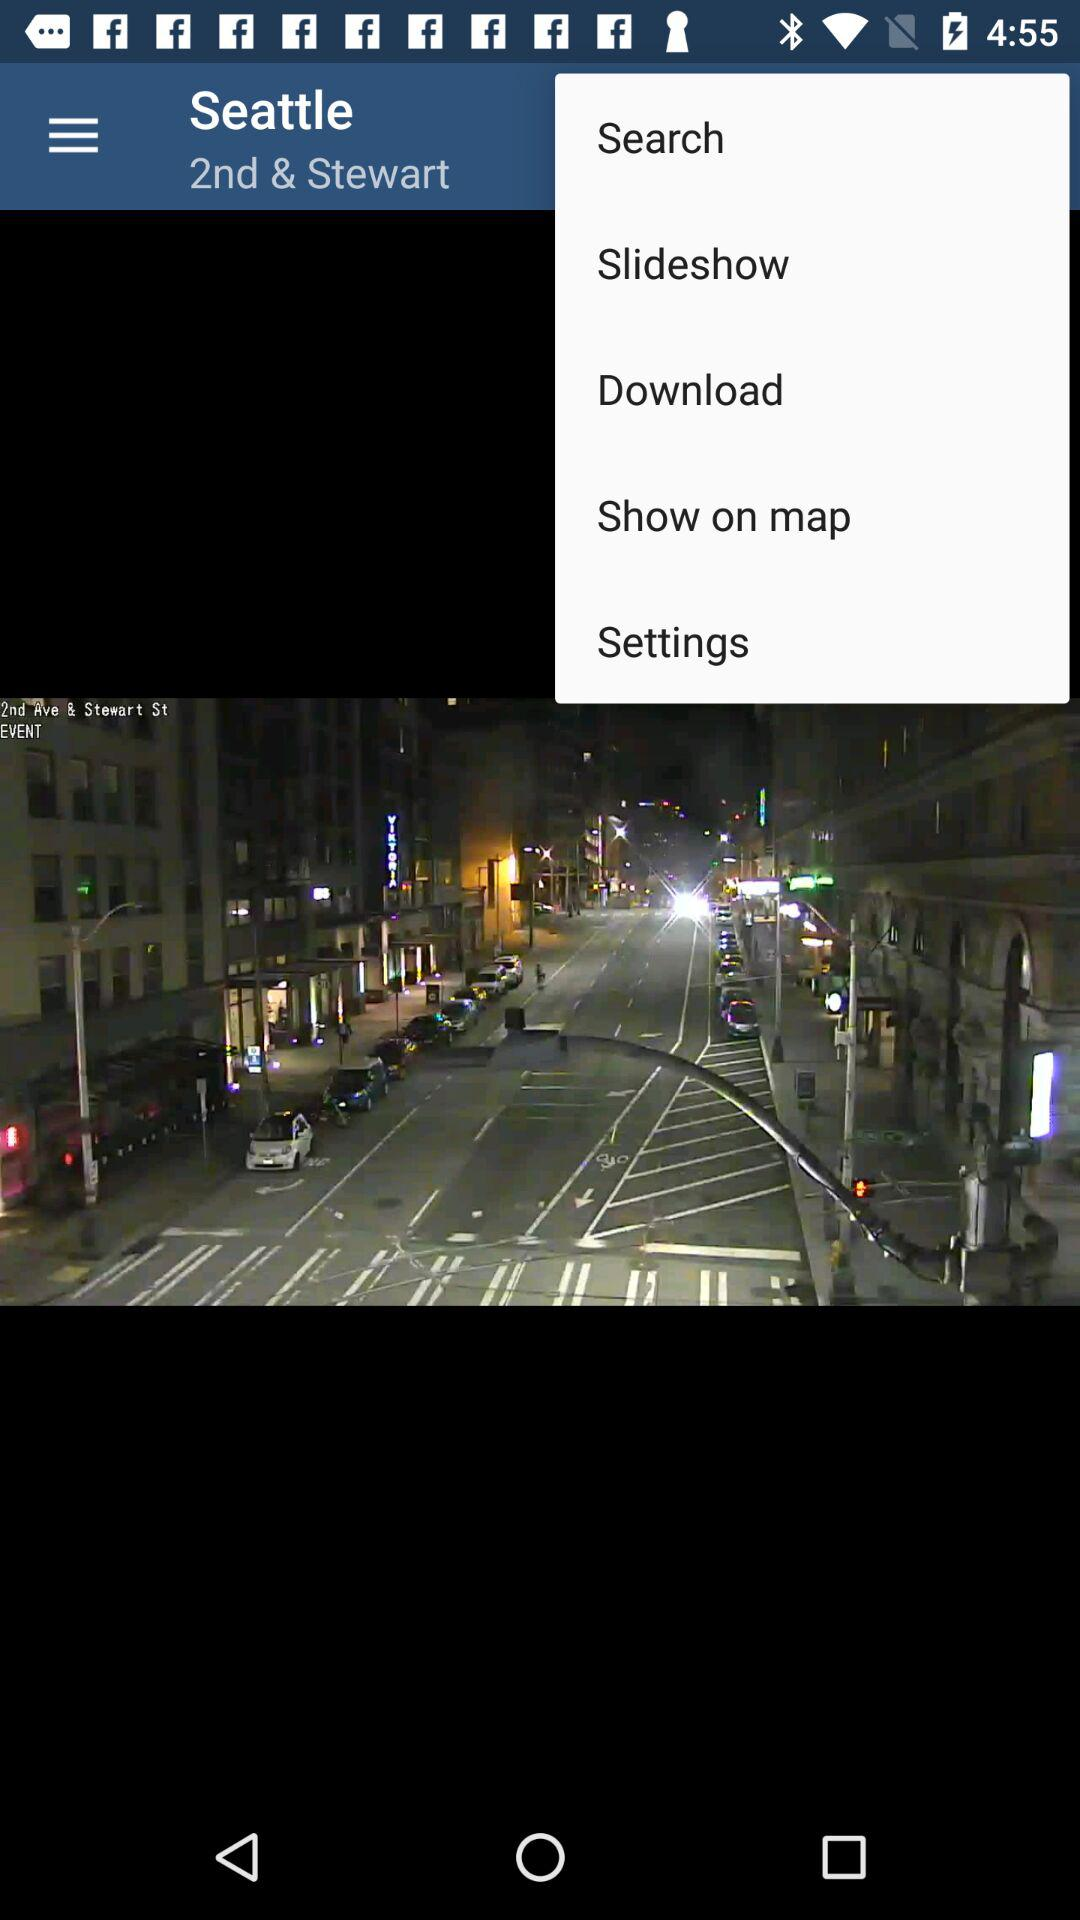What is the mentioned location? The mentioned location is 2nd & Stewart, Seattle. 